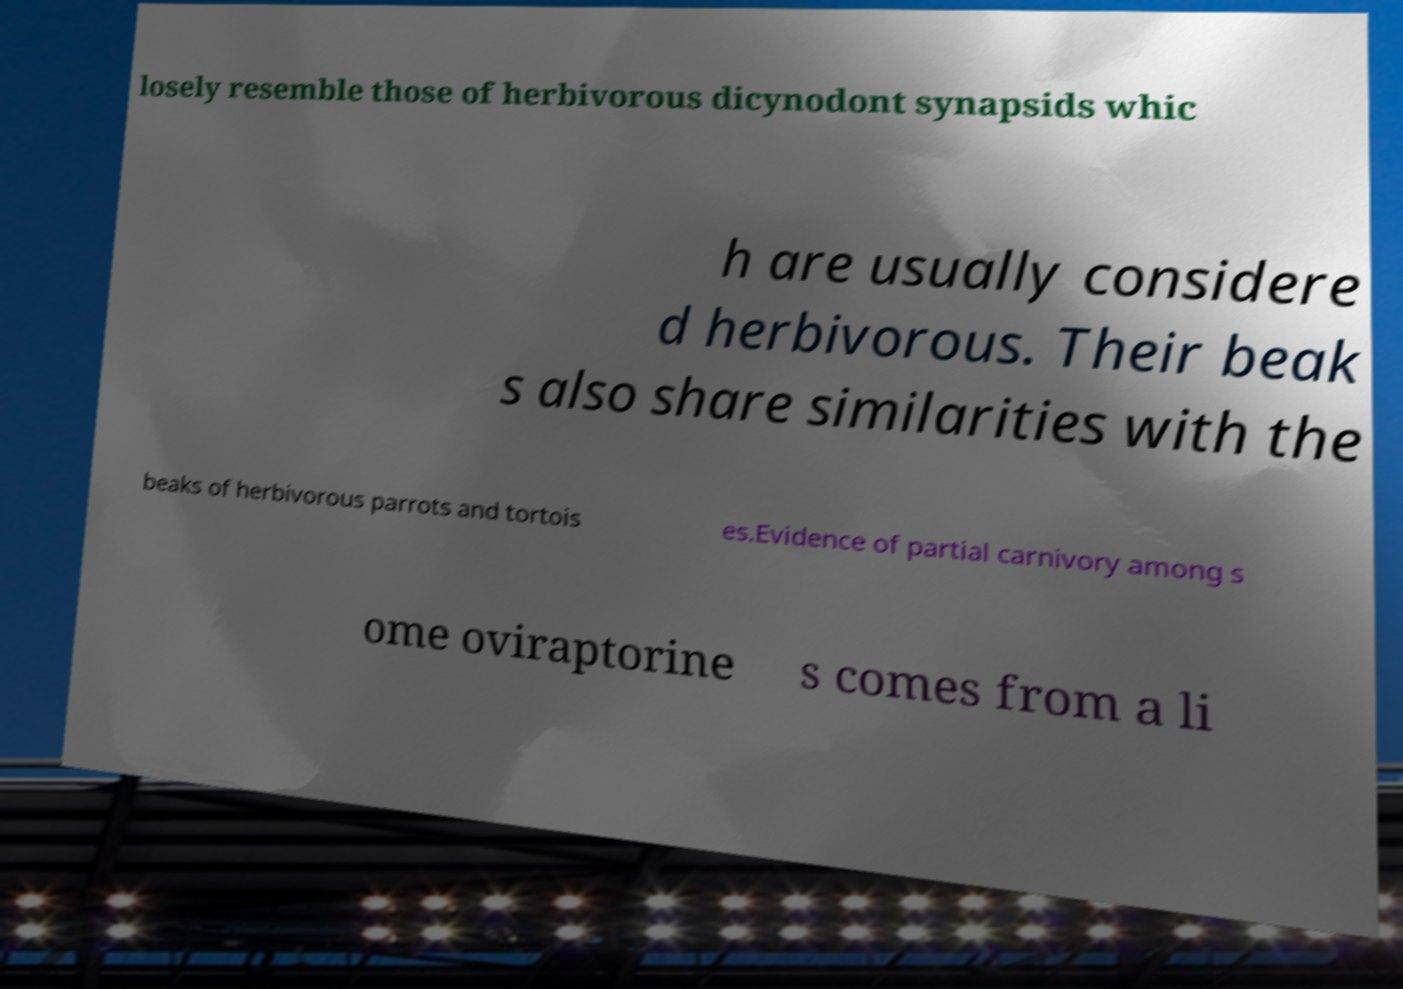There's text embedded in this image that I need extracted. Can you transcribe it verbatim? losely resemble those of herbivorous dicynodont synapsids whic h are usually considere d herbivorous. Their beak s also share similarities with the beaks of herbivorous parrots and tortois es.Evidence of partial carnivory among s ome oviraptorine s comes from a li 